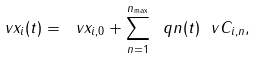Convert formula to latex. <formula><loc_0><loc_0><loc_500><loc_500>\ v x _ { i } ( t ) = \ v x _ { i , 0 } + \sum _ { n = 1 } ^ { n _ { \max } } \ q n ( t ) \ v C _ { i , n } ,</formula> 